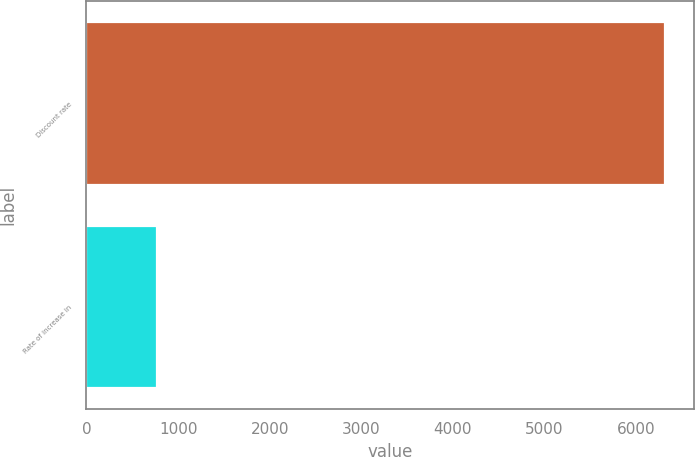Convert chart to OTSL. <chart><loc_0><loc_0><loc_500><loc_500><bar_chart><fcel>Discount rate<fcel>Rate of increase in<nl><fcel>6312<fcel>775<nl></chart> 